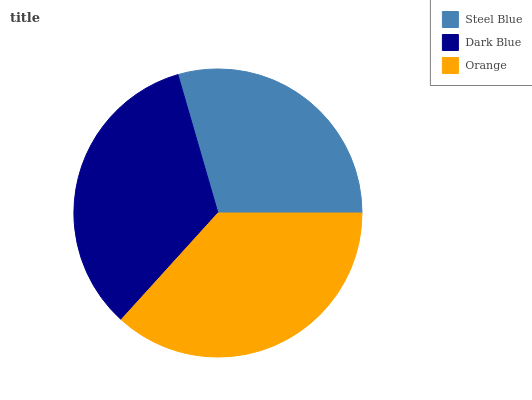Is Steel Blue the minimum?
Answer yes or no. Yes. Is Orange the maximum?
Answer yes or no. Yes. Is Dark Blue the minimum?
Answer yes or no. No. Is Dark Blue the maximum?
Answer yes or no. No. Is Dark Blue greater than Steel Blue?
Answer yes or no. Yes. Is Steel Blue less than Dark Blue?
Answer yes or no. Yes. Is Steel Blue greater than Dark Blue?
Answer yes or no. No. Is Dark Blue less than Steel Blue?
Answer yes or no. No. Is Dark Blue the high median?
Answer yes or no. Yes. Is Dark Blue the low median?
Answer yes or no. Yes. Is Orange the high median?
Answer yes or no. No. Is Orange the low median?
Answer yes or no. No. 